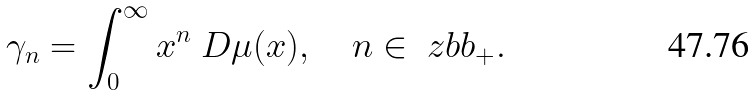<formula> <loc_0><loc_0><loc_500><loc_500>\gamma _ { n } = \int _ { 0 } ^ { \infty } x ^ { n } \ D \mu ( x ) , \quad n \in \ z b b _ { + } .</formula> 